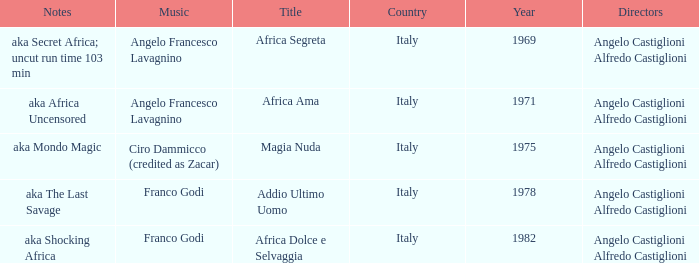How many years have a Title of Magia Nuda? 1.0. 